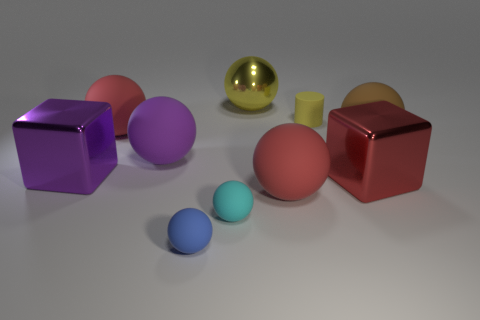Are any small cyan things visible?
Offer a terse response. Yes. The metal object that is on the left side of the small blue rubber thing is what color?
Ensure brevity in your answer.  Purple. What material is the ball that is the same color as the matte cylinder?
Your response must be concise. Metal. Are there any metallic balls to the right of the big red cube?
Make the answer very short. No. Are there more large purple matte objects than big blocks?
Provide a succinct answer. No. There is a metal thing that is left of the big red rubber object that is left of the matte sphere that is in front of the small cyan ball; what color is it?
Provide a short and direct response. Purple. What color is the cylinder that is made of the same material as the brown ball?
Provide a short and direct response. Yellow. Is there anything else that is the same size as the brown matte object?
Give a very brief answer. Yes. What number of objects are either large balls that are on the right side of the small cyan thing or big objects that are in front of the brown ball?
Your answer should be very brief. 6. Does the red rubber sphere behind the brown matte thing have the same size as the cylinder that is in front of the yellow shiny ball?
Ensure brevity in your answer.  No. 